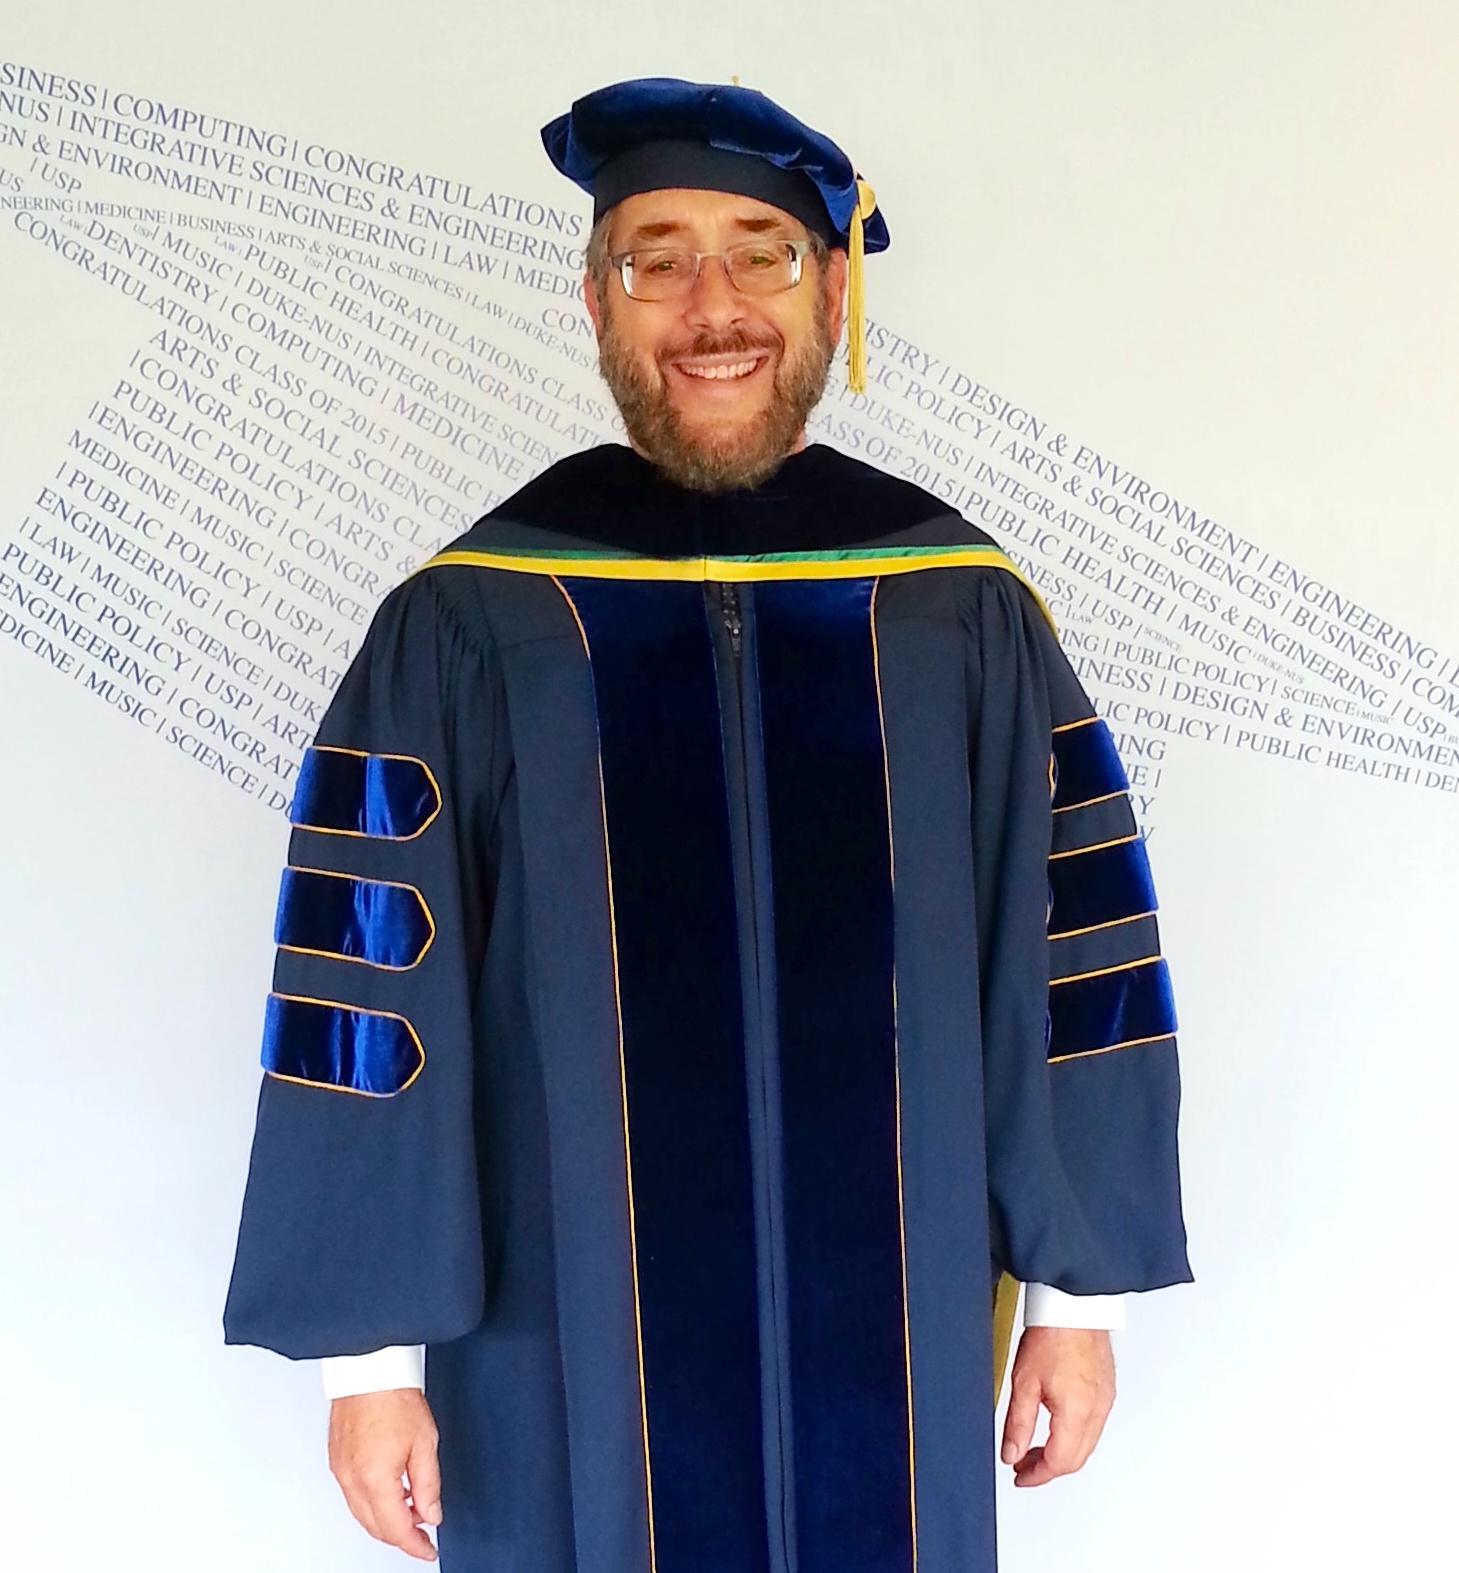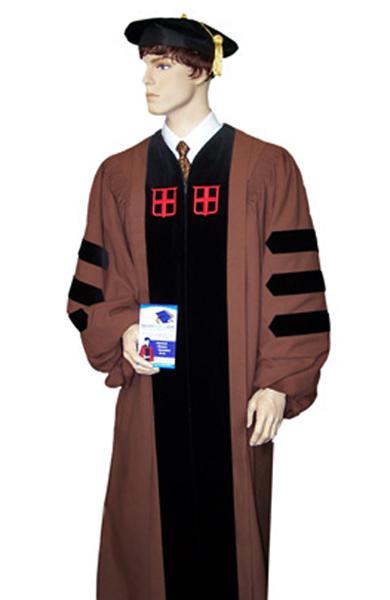The first image is the image on the left, the second image is the image on the right. Assess this claim about the two images: "An image shows a mannequin wearing a graduation robe with black stripes on its sleeves.". Correct or not? Answer yes or no. Yes. The first image is the image on the left, the second image is the image on the right. Examine the images to the left and right. Is the description "All graduation gowns and caps with tassles are modeled by real people, but only person is shown full length from head to foot." accurate? Answer yes or no. No. 